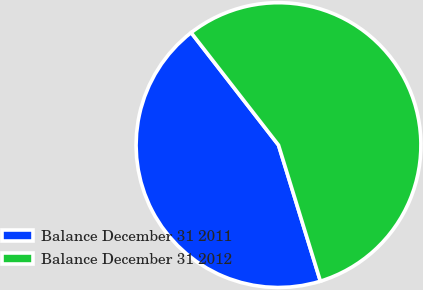Convert chart. <chart><loc_0><loc_0><loc_500><loc_500><pie_chart><fcel>Balance December 31 2011<fcel>Balance December 31 2012<nl><fcel>44.24%<fcel>55.76%<nl></chart> 